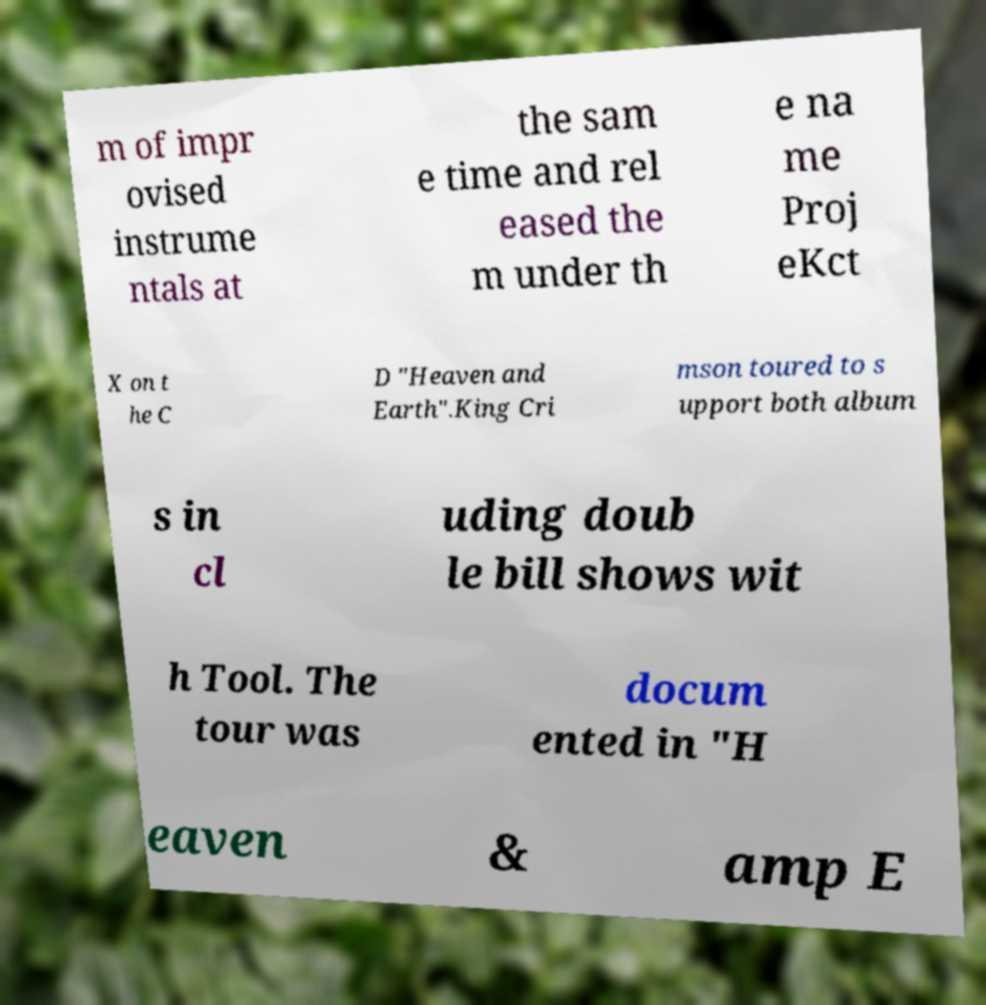There's text embedded in this image that I need extracted. Can you transcribe it verbatim? m of impr ovised instrume ntals at the sam e time and rel eased the m under th e na me Proj eKct X on t he C D "Heaven and Earth".King Cri mson toured to s upport both album s in cl uding doub le bill shows wit h Tool. The tour was docum ented in "H eaven & amp E 